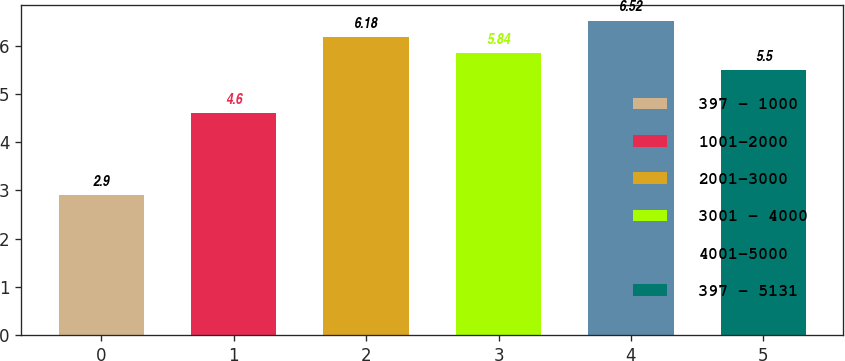Convert chart. <chart><loc_0><loc_0><loc_500><loc_500><bar_chart><fcel>397 - 1000<fcel>1001-2000<fcel>2001-3000<fcel>3001 - 4000<fcel>4001-5000<fcel>397 - 5131<nl><fcel>2.9<fcel>4.6<fcel>6.18<fcel>5.84<fcel>6.52<fcel>5.5<nl></chart> 